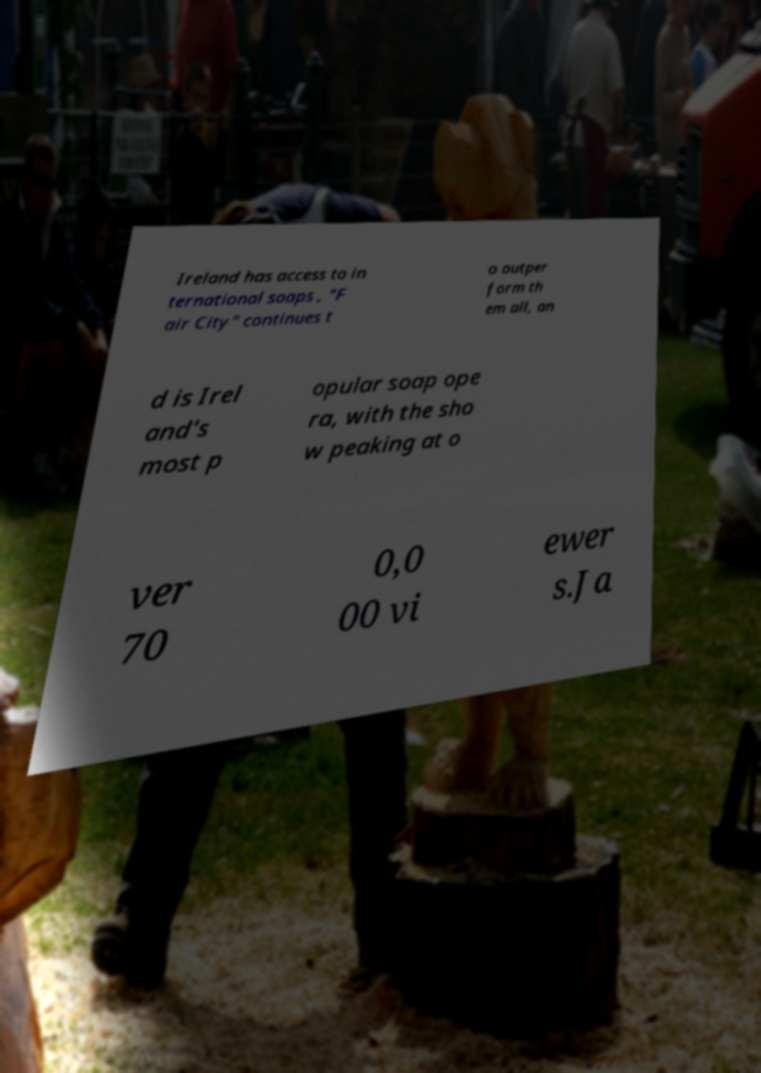Can you accurately transcribe the text from the provided image for me? Ireland has access to in ternational soaps , "F air City" continues t o outper form th em all, an d is Irel and's most p opular soap ope ra, with the sho w peaking at o ver 70 0,0 00 vi ewer s.Ja 